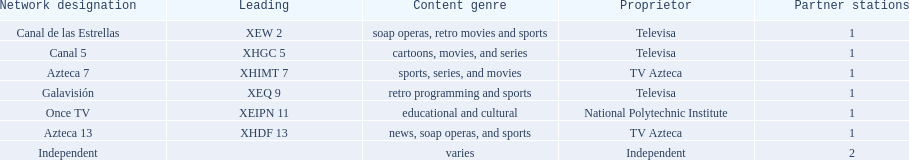Who are the owners of the stations listed here? Televisa, Televisa, TV Azteca, Televisa, National Polytechnic Institute, TV Azteca, Independent. What is the one station owned by national polytechnic institute? Once TV. 